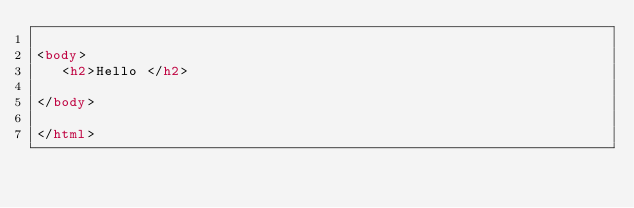<code> <loc_0><loc_0><loc_500><loc_500><_HTML_>
<body>
   <h2>Hello </h2>

</body>

</html></code> 